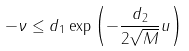Convert formula to latex. <formula><loc_0><loc_0><loc_500><loc_500>- \nu \leq d _ { 1 } \exp \left ( - \frac { d _ { 2 } } { 2 \sqrt { M } } u \right )</formula> 